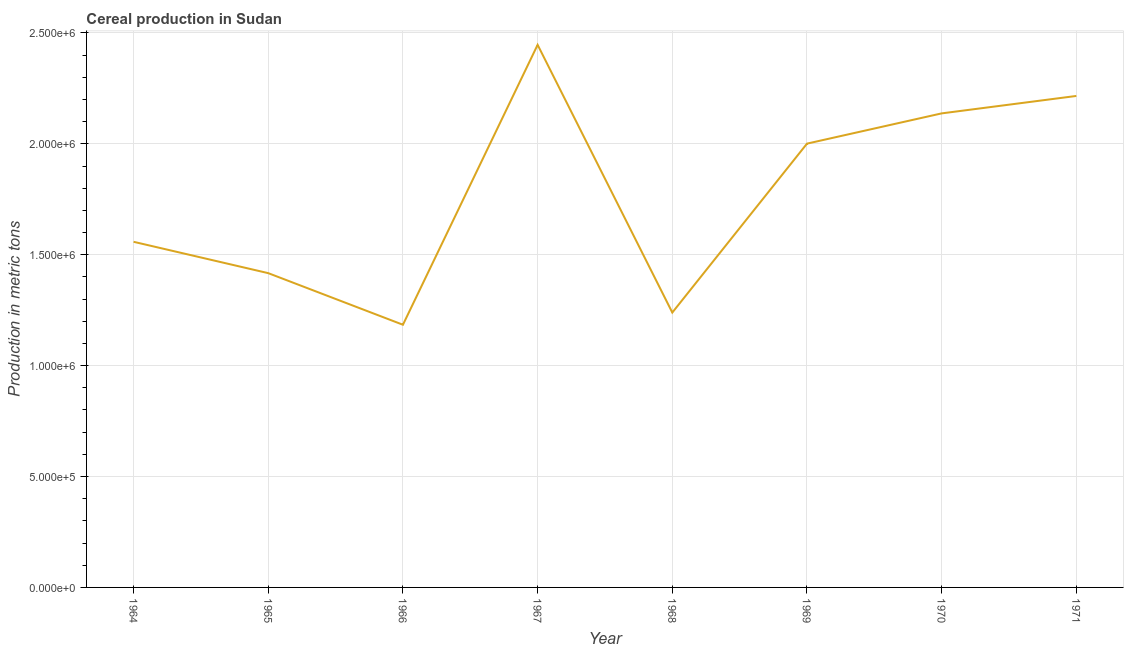What is the cereal production in 1965?
Make the answer very short. 1.42e+06. Across all years, what is the maximum cereal production?
Your response must be concise. 2.45e+06. Across all years, what is the minimum cereal production?
Offer a very short reply. 1.18e+06. In which year was the cereal production maximum?
Make the answer very short. 1967. In which year was the cereal production minimum?
Your answer should be compact. 1966. What is the sum of the cereal production?
Keep it short and to the point. 1.42e+07. What is the difference between the cereal production in 1965 and 1969?
Your answer should be compact. -5.84e+05. What is the average cereal production per year?
Offer a terse response. 1.78e+06. What is the median cereal production?
Ensure brevity in your answer.  1.78e+06. What is the ratio of the cereal production in 1966 to that in 1969?
Offer a very short reply. 0.59. Is the cereal production in 1964 less than that in 1969?
Provide a succinct answer. Yes. What is the difference between the highest and the second highest cereal production?
Your response must be concise. 2.31e+05. Is the sum of the cereal production in 1964 and 1971 greater than the maximum cereal production across all years?
Offer a very short reply. Yes. What is the difference between the highest and the lowest cereal production?
Provide a short and direct response. 1.26e+06. In how many years, is the cereal production greater than the average cereal production taken over all years?
Your answer should be compact. 4. Does the cereal production monotonically increase over the years?
Offer a very short reply. No. Are the values on the major ticks of Y-axis written in scientific E-notation?
Your answer should be very brief. Yes. Does the graph contain grids?
Your answer should be very brief. Yes. What is the title of the graph?
Make the answer very short. Cereal production in Sudan. What is the label or title of the Y-axis?
Keep it short and to the point. Production in metric tons. What is the Production in metric tons of 1964?
Your answer should be very brief. 1.56e+06. What is the Production in metric tons of 1965?
Your answer should be very brief. 1.42e+06. What is the Production in metric tons of 1966?
Make the answer very short. 1.18e+06. What is the Production in metric tons in 1967?
Keep it short and to the point. 2.45e+06. What is the Production in metric tons in 1968?
Make the answer very short. 1.24e+06. What is the Production in metric tons in 1969?
Make the answer very short. 2.00e+06. What is the Production in metric tons of 1970?
Your answer should be compact. 2.14e+06. What is the Production in metric tons of 1971?
Offer a terse response. 2.22e+06. What is the difference between the Production in metric tons in 1964 and 1965?
Your answer should be very brief. 1.41e+05. What is the difference between the Production in metric tons in 1964 and 1966?
Your answer should be compact. 3.74e+05. What is the difference between the Production in metric tons in 1964 and 1967?
Keep it short and to the point. -8.88e+05. What is the difference between the Production in metric tons in 1964 and 1968?
Give a very brief answer. 3.19e+05. What is the difference between the Production in metric tons in 1964 and 1969?
Your answer should be very brief. -4.43e+05. What is the difference between the Production in metric tons in 1964 and 1970?
Ensure brevity in your answer.  -5.79e+05. What is the difference between the Production in metric tons in 1964 and 1971?
Make the answer very short. -6.58e+05. What is the difference between the Production in metric tons in 1965 and 1966?
Make the answer very short. 2.33e+05. What is the difference between the Production in metric tons in 1965 and 1967?
Your answer should be very brief. -1.03e+06. What is the difference between the Production in metric tons in 1965 and 1968?
Your response must be concise. 1.78e+05. What is the difference between the Production in metric tons in 1965 and 1969?
Make the answer very short. -5.84e+05. What is the difference between the Production in metric tons in 1965 and 1970?
Give a very brief answer. -7.20e+05. What is the difference between the Production in metric tons in 1965 and 1971?
Provide a succinct answer. -7.99e+05. What is the difference between the Production in metric tons in 1966 and 1967?
Your response must be concise. -1.26e+06. What is the difference between the Production in metric tons in 1966 and 1968?
Keep it short and to the point. -5.50e+04. What is the difference between the Production in metric tons in 1966 and 1969?
Your answer should be compact. -8.17e+05. What is the difference between the Production in metric tons in 1966 and 1970?
Your response must be concise. -9.53e+05. What is the difference between the Production in metric tons in 1966 and 1971?
Give a very brief answer. -1.03e+06. What is the difference between the Production in metric tons in 1967 and 1968?
Provide a succinct answer. 1.21e+06. What is the difference between the Production in metric tons in 1967 and 1969?
Your answer should be compact. 4.46e+05. What is the difference between the Production in metric tons in 1967 and 1970?
Provide a succinct answer. 3.09e+05. What is the difference between the Production in metric tons in 1967 and 1971?
Your response must be concise. 2.31e+05. What is the difference between the Production in metric tons in 1968 and 1969?
Provide a short and direct response. -7.62e+05. What is the difference between the Production in metric tons in 1968 and 1970?
Your answer should be very brief. -8.98e+05. What is the difference between the Production in metric tons in 1968 and 1971?
Your answer should be compact. -9.77e+05. What is the difference between the Production in metric tons in 1969 and 1970?
Ensure brevity in your answer.  -1.36e+05. What is the difference between the Production in metric tons in 1969 and 1971?
Your answer should be very brief. -2.15e+05. What is the difference between the Production in metric tons in 1970 and 1971?
Keep it short and to the point. -7.86e+04. What is the ratio of the Production in metric tons in 1964 to that in 1966?
Your answer should be very brief. 1.32. What is the ratio of the Production in metric tons in 1964 to that in 1967?
Keep it short and to the point. 0.64. What is the ratio of the Production in metric tons in 1964 to that in 1968?
Your response must be concise. 1.26. What is the ratio of the Production in metric tons in 1964 to that in 1969?
Ensure brevity in your answer.  0.78. What is the ratio of the Production in metric tons in 1964 to that in 1970?
Your answer should be very brief. 0.73. What is the ratio of the Production in metric tons in 1964 to that in 1971?
Provide a short and direct response. 0.7. What is the ratio of the Production in metric tons in 1965 to that in 1966?
Your response must be concise. 1.2. What is the ratio of the Production in metric tons in 1965 to that in 1967?
Offer a terse response. 0.58. What is the ratio of the Production in metric tons in 1965 to that in 1968?
Offer a very short reply. 1.14. What is the ratio of the Production in metric tons in 1965 to that in 1969?
Offer a terse response. 0.71. What is the ratio of the Production in metric tons in 1965 to that in 1970?
Your answer should be compact. 0.66. What is the ratio of the Production in metric tons in 1965 to that in 1971?
Give a very brief answer. 0.64. What is the ratio of the Production in metric tons in 1966 to that in 1967?
Keep it short and to the point. 0.48. What is the ratio of the Production in metric tons in 1966 to that in 1968?
Your answer should be compact. 0.96. What is the ratio of the Production in metric tons in 1966 to that in 1969?
Offer a terse response. 0.59. What is the ratio of the Production in metric tons in 1966 to that in 1970?
Offer a very short reply. 0.55. What is the ratio of the Production in metric tons in 1966 to that in 1971?
Provide a short and direct response. 0.53. What is the ratio of the Production in metric tons in 1967 to that in 1968?
Make the answer very short. 1.97. What is the ratio of the Production in metric tons in 1967 to that in 1969?
Give a very brief answer. 1.22. What is the ratio of the Production in metric tons in 1967 to that in 1970?
Give a very brief answer. 1.15. What is the ratio of the Production in metric tons in 1967 to that in 1971?
Provide a succinct answer. 1.1. What is the ratio of the Production in metric tons in 1968 to that in 1969?
Give a very brief answer. 0.62. What is the ratio of the Production in metric tons in 1968 to that in 1970?
Offer a very short reply. 0.58. What is the ratio of the Production in metric tons in 1968 to that in 1971?
Provide a succinct answer. 0.56. What is the ratio of the Production in metric tons in 1969 to that in 1970?
Give a very brief answer. 0.94. What is the ratio of the Production in metric tons in 1969 to that in 1971?
Provide a succinct answer. 0.9. What is the ratio of the Production in metric tons in 1970 to that in 1971?
Keep it short and to the point. 0.96. 